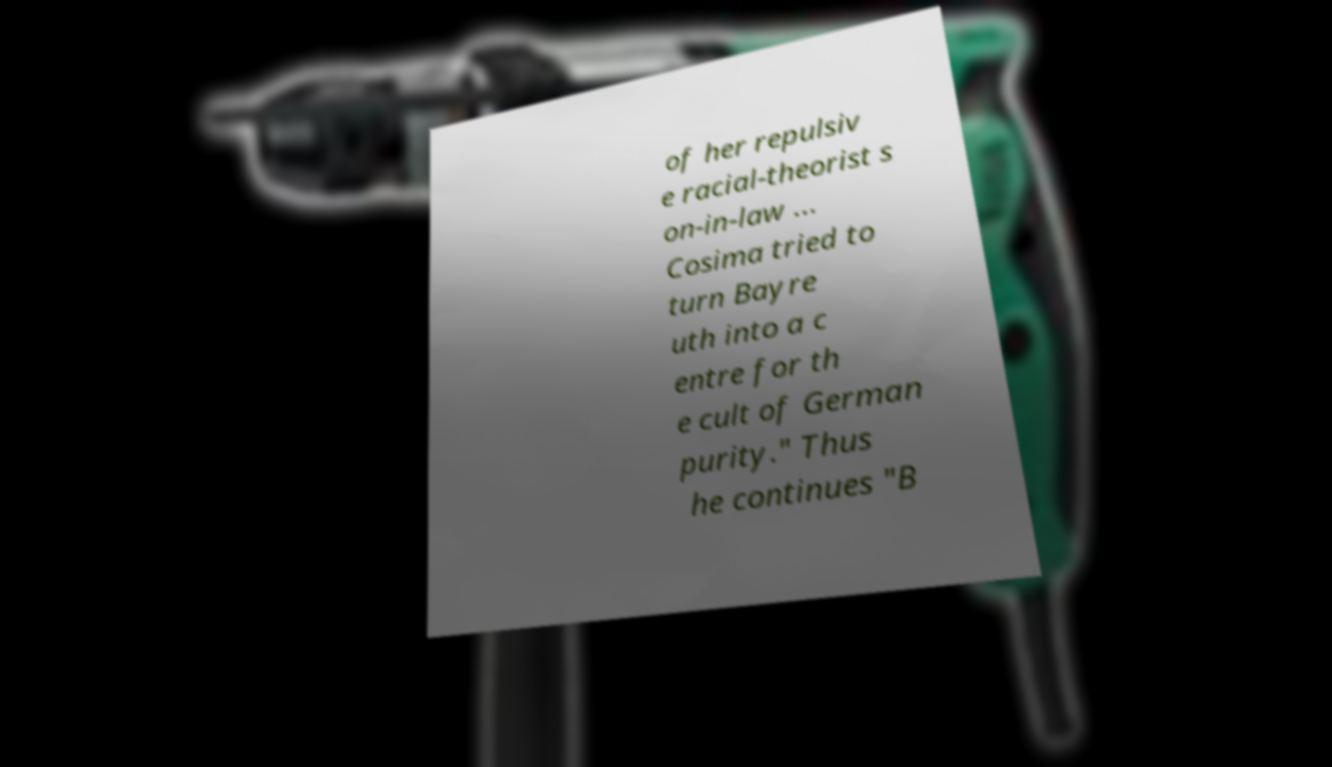Can you read and provide the text displayed in the image?This photo seems to have some interesting text. Can you extract and type it out for me? of her repulsiv e racial-theorist s on-in-law ... Cosima tried to turn Bayre uth into a c entre for th e cult of German purity." Thus he continues "B 